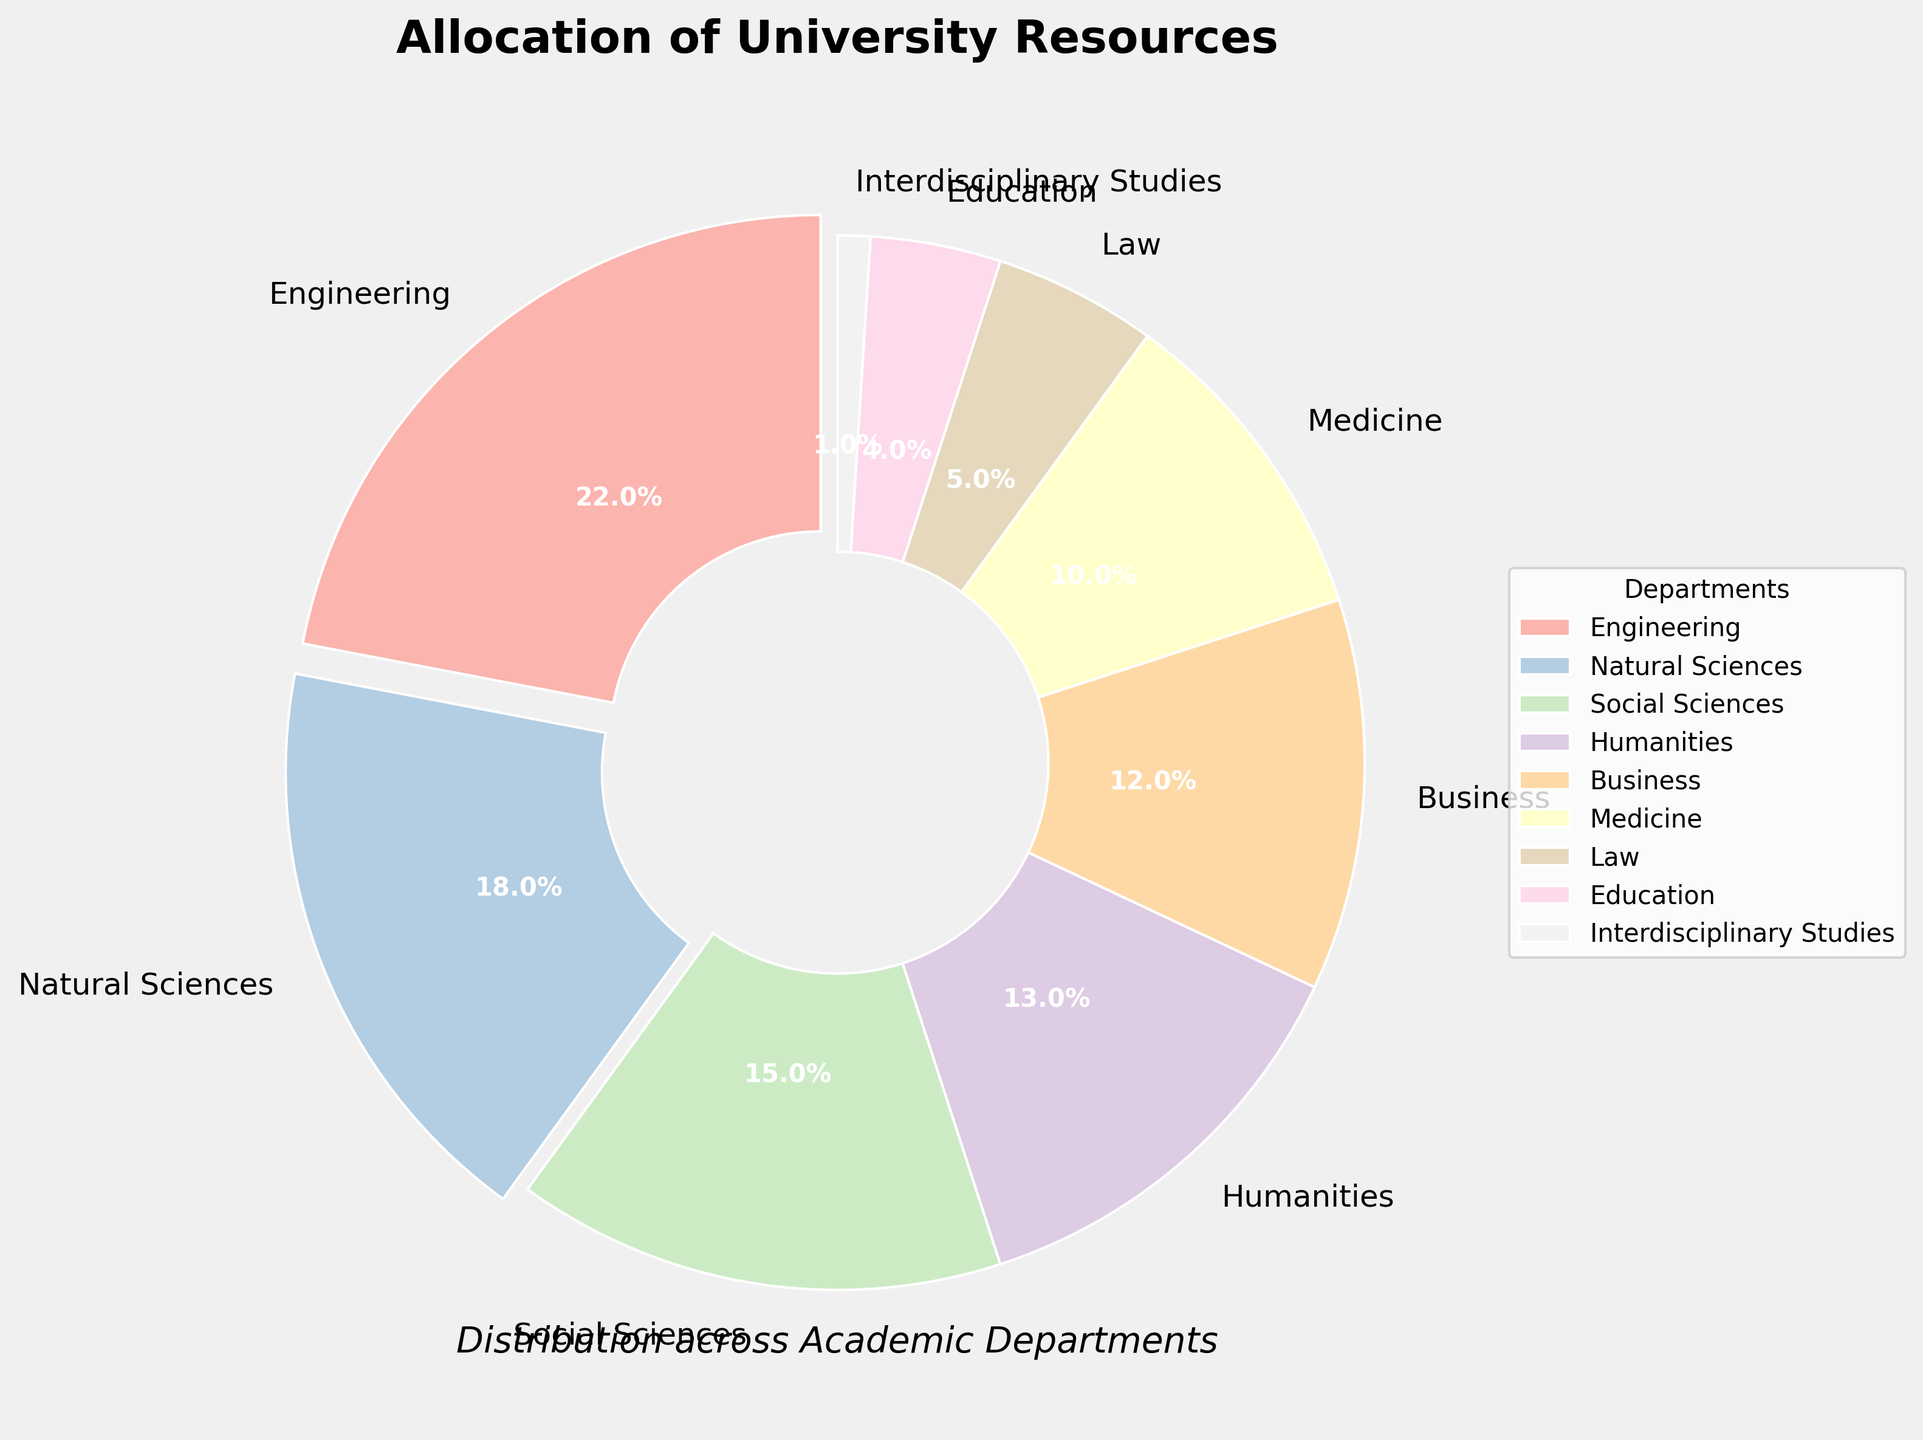Which department receives the highest budget allocation? By looking at the pie chart, the department with the largest pie slice represents the highest budget allocation. The slice labeled "Engineering" is the largest, indicating it receives the highest allocation.
Answer: Engineering Which departments have a budget allocation greater than 15%? Observing the pie chart, the departments with slices that appear larger than the 15% marker have higher allocations. The labels "Engineering" and "Natural Sciences" are clearly larger than these portions.
Answer: Engineering, Natural Sciences What is the combined budget allocation for Humanities and Medicine? From the pie chart, the allotment for Humanities is 13% and for Medicine is 10%. Adding them together, the combined allocation is 13% + 10%.
Answer: 23% Which department has the smallest budget allocation? The department with the smallest slice on the pie chart indicates the smallest allocation. The slice labeled "Interdisciplinary Studies" is the smallest.
Answer: Interdisciplinary Studies Which two departments have the closest budget allocations, and what are those allocations? By comparing the sizes of the slices around similar ranges, the two slices for Law and Education seem closest in size, with allocations of 5% and 4% respectively.
Answer: Law and Education, 5% and 4% What percentage of the budget is allocated to departments other than Engineering and Natural Sciences? First, add the percentage of Engineering and Natural Sciences (22% + 18% = 40%). Subtract this from 100% to find the remaining percentage distributed to other departments (100% - 40% = 60%).
Answer: 60% Which department’s slice is directly next to Medicine’s slice in the clockwise direction? Observing the pie chart, the slice after Medicine (10%) in the clockwise direction is Law (5%).
Answer: Law If you combine the allocations of Business and Education, does their combined allocation exceed that of Social Sciences? From the pie chart, Business has 12% and Education has 4%. Their combined allocation is 12% + 4% = 16%. Social Sciences have 15%, so 16% is greater.
Answer: Yes What portion of the chart's color is used for Engineering? The largest pie slice representing Engineering would occupy a significant portion of the color spectrum in the pie chart, specifically 22% of the chart.
Answer: 22% Which academic department share is closest to Medicine in percentage terms? Comparing the percentages, Law at 5% is the closest to Medicine's 10%, in relation to the percentage difference.
Answer: Law 